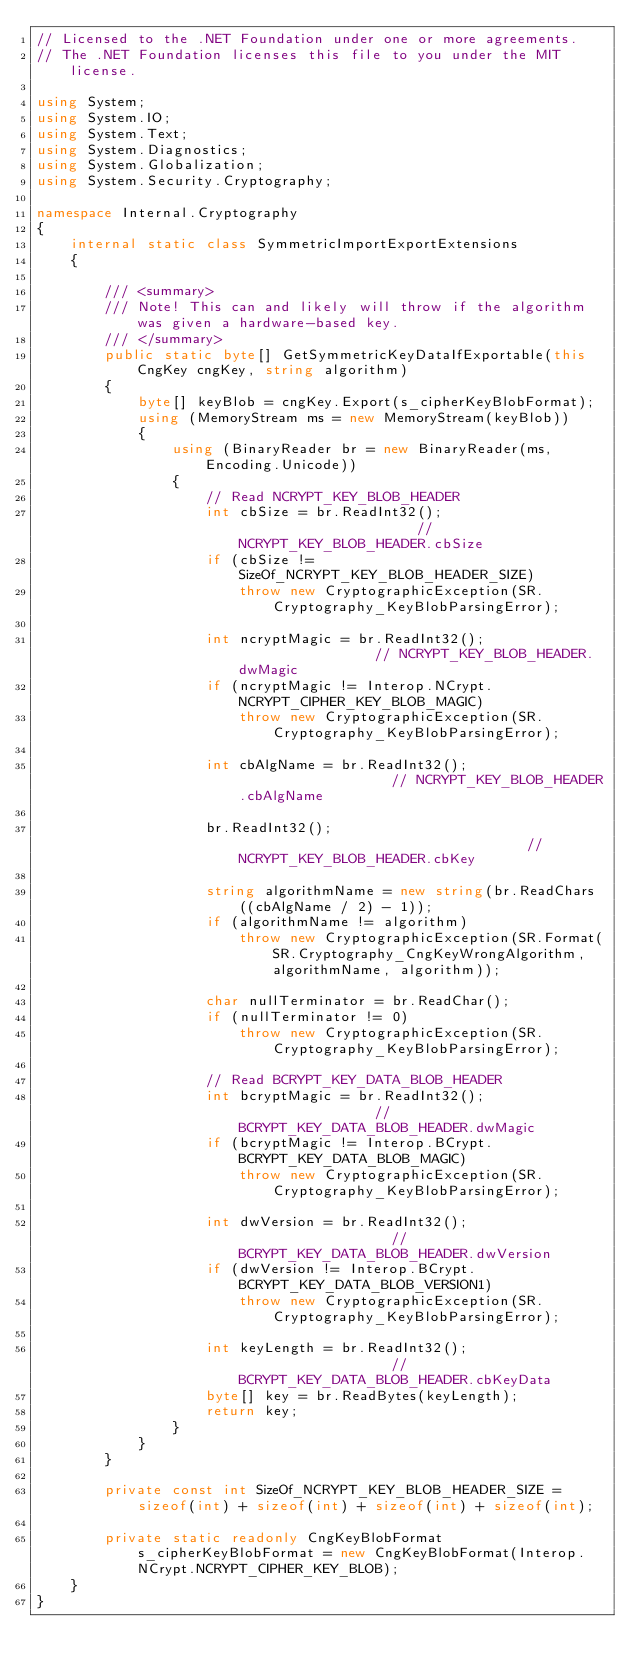Convert code to text. <code><loc_0><loc_0><loc_500><loc_500><_C#_>// Licensed to the .NET Foundation under one or more agreements.
// The .NET Foundation licenses this file to you under the MIT license.

using System;
using System.IO;
using System.Text;
using System.Diagnostics;
using System.Globalization;
using System.Security.Cryptography;

namespace Internal.Cryptography
{
    internal static class SymmetricImportExportExtensions
    {

        /// <summary>
        /// Note! This can and likely will throw if the algorithm was given a hardware-based key.
        /// </summary>
        public static byte[] GetSymmetricKeyDataIfExportable(this CngKey cngKey, string algorithm)
        {
            byte[] keyBlob = cngKey.Export(s_cipherKeyBlobFormat);
            using (MemoryStream ms = new MemoryStream(keyBlob))
            {
                using (BinaryReader br = new BinaryReader(ms, Encoding.Unicode))
                {
                    // Read NCRYPT_KEY_BLOB_HEADER
                    int cbSize = br.ReadInt32();                      // NCRYPT_KEY_BLOB_HEADER.cbSize
                    if (cbSize != SizeOf_NCRYPT_KEY_BLOB_HEADER_SIZE)
                        throw new CryptographicException(SR.Cryptography_KeyBlobParsingError);

                    int ncryptMagic = br.ReadInt32();                 // NCRYPT_KEY_BLOB_HEADER.dwMagic
                    if (ncryptMagic != Interop.NCrypt.NCRYPT_CIPHER_KEY_BLOB_MAGIC)
                        throw new CryptographicException(SR.Cryptography_KeyBlobParsingError);

                    int cbAlgName = br.ReadInt32();                   // NCRYPT_KEY_BLOB_HEADER.cbAlgName

                    br.ReadInt32();                                   // NCRYPT_KEY_BLOB_HEADER.cbKey

                    string algorithmName = new string(br.ReadChars((cbAlgName / 2) - 1));
                    if (algorithmName != algorithm)
                        throw new CryptographicException(SR.Format(SR.Cryptography_CngKeyWrongAlgorithm, algorithmName, algorithm));

                    char nullTerminator = br.ReadChar();
                    if (nullTerminator != 0)
                        throw new CryptographicException(SR.Cryptography_KeyBlobParsingError);

                    // Read BCRYPT_KEY_DATA_BLOB_HEADER
                    int bcryptMagic = br.ReadInt32();                 // BCRYPT_KEY_DATA_BLOB_HEADER.dwMagic
                    if (bcryptMagic != Interop.BCrypt.BCRYPT_KEY_DATA_BLOB_MAGIC)
                        throw new CryptographicException(SR.Cryptography_KeyBlobParsingError);

                    int dwVersion = br.ReadInt32();                   // BCRYPT_KEY_DATA_BLOB_HEADER.dwVersion
                    if (dwVersion != Interop.BCrypt.BCRYPT_KEY_DATA_BLOB_VERSION1)
                        throw new CryptographicException(SR.Cryptography_KeyBlobParsingError);

                    int keyLength = br.ReadInt32();                   // BCRYPT_KEY_DATA_BLOB_HEADER.cbKeyData
                    byte[] key = br.ReadBytes(keyLength);
                    return key;
                }
            }
        }

        private const int SizeOf_NCRYPT_KEY_BLOB_HEADER_SIZE = sizeof(int) + sizeof(int) + sizeof(int) + sizeof(int);

        private static readonly CngKeyBlobFormat s_cipherKeyBlobFormat = new CngKeyBlobFormat(Interop.NCrypt.NCRYPT_CIPHER_KEY_BLOB);
    }
}
</code> 